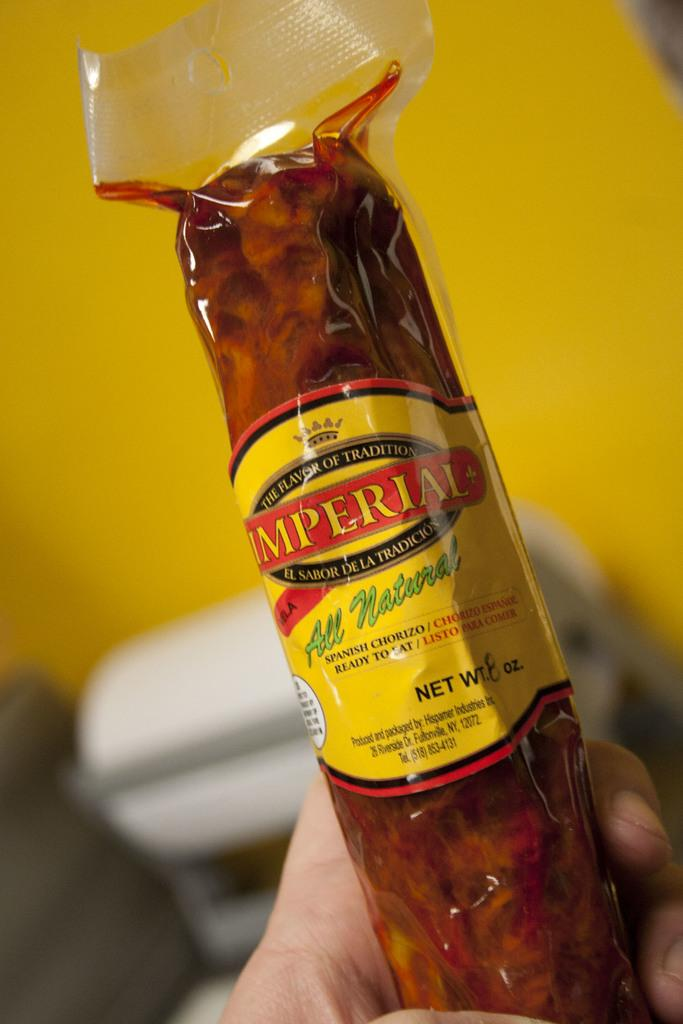<image>
Describe the image concisely. a package of spanish chorizo labeled as imperial 